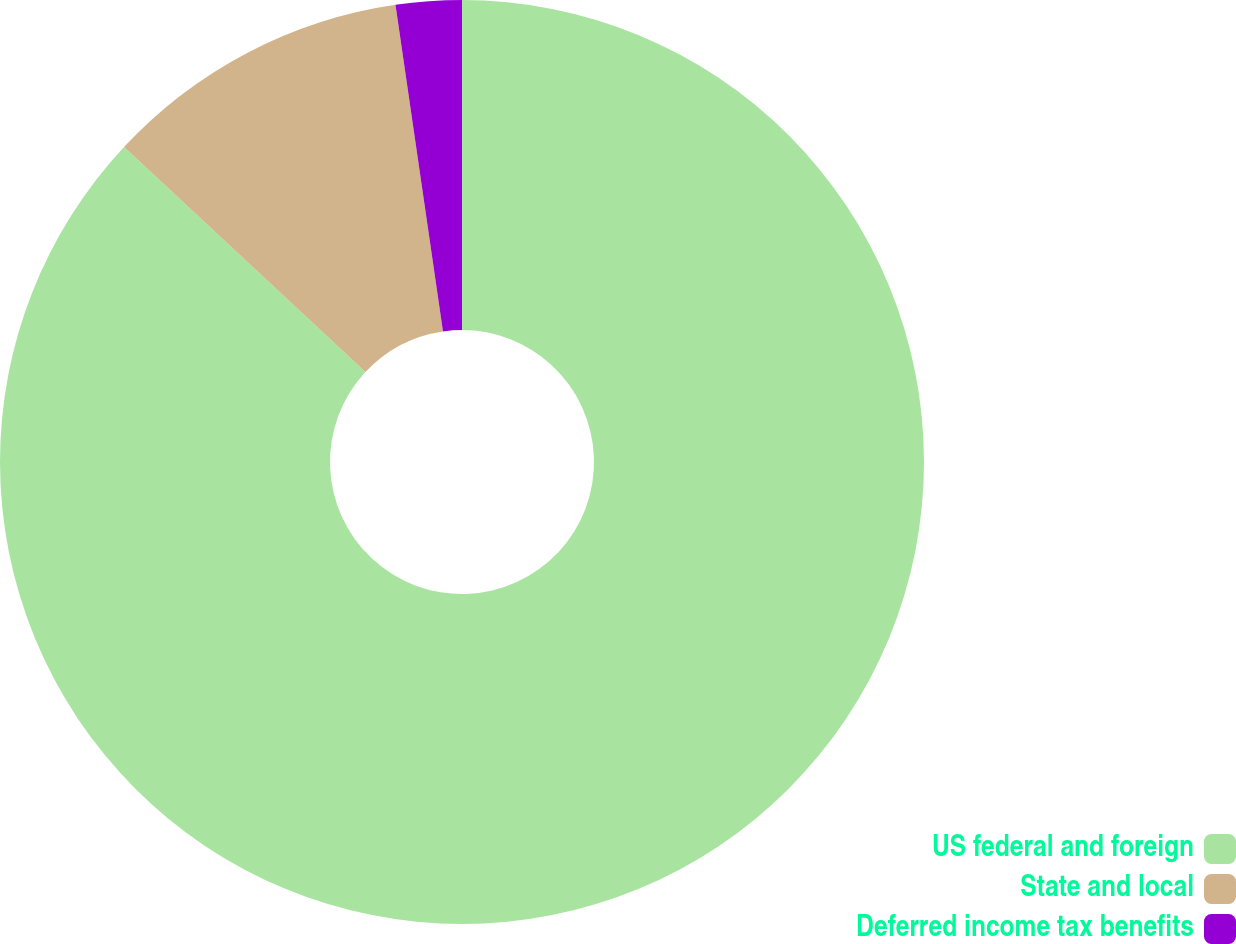Convert chart. <chart><loc_0><loc_0><loc_500><loc_500><pie_chart><fcel>US federal and foreign<fcel>State and local<fcel>Deferred income tax benefits<nl><fcel>86.94%<fcel>10.76%<fcel>2.3%<nl></chart> 